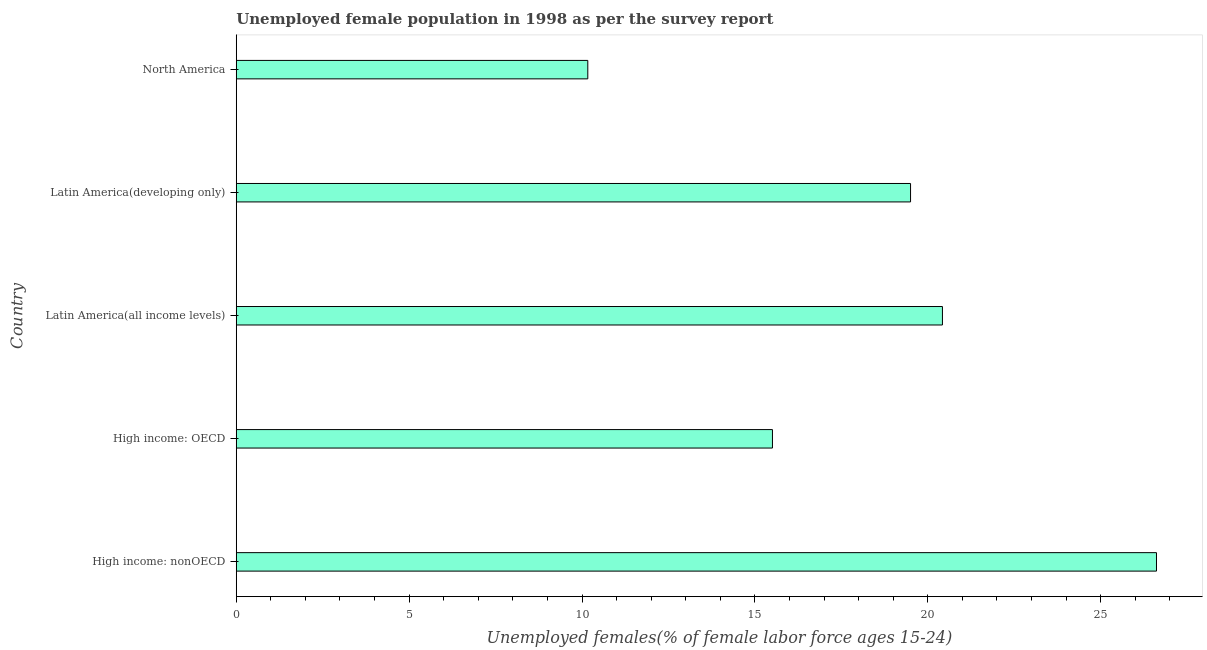Does the graph contain grids?
Provide a short and direct response. No. What is the title of the graph?
Offer a very short reply. Unemployed female population in 1998 as per the survey report. What is the label or title of the X-axis?
Your answer should be compact. Unemployed females(% of female labor force ages 15-24). What is the unemployed female youth in High income: nonOECD?
Offer a very short reply. 26.61. Across all countries, what is the maximum unemployed female youth?
Keep it short and to the point. 26.61. Across all countries, what is the minimum unemployed female youth?
Ensure brevity in your answer.  10.17. In which country was the unemployed female youth maximum?
Make the answer very short. High income: nonOECD. In which country was the unemployed female youth minimum?
Keep it short and to the point. North America. What is the sum of the unemployed female youth?
Make the answer very short. 92.21. What is the difference between the unemployed female youth in High income: OECD and Latin America(developing only)?
Your response must be concise. -3.99. What is the average unemployed female youth per country?
Ensure brevity in your answer.  18.44. What is the median unemployed female youth?
Make the answer very short. 19.5. What is the ratio of the unemployed female youth in High income: nonOECD to that in Latin America(developing only)?
Your answer should be compact. 1.36. Is the unemployed female youth in High income: OECD less than that in North America?
Ensure brevity in your answer.  No. Is the difference between the unemployed female youth in High income: OECD and Latin America(all income levels) greater than the difference between any two countries?
Ensure brevity in your answer.  No. What is the difference between the highest and the second highest unemployed female youth?
Keep it short and to the point. 6.19. Is the sum of the unemployed female youth in High income: OECD and North America greater than the maximum unemployed female youth across all countries?
Offer a very short reply. No. What is the difference between the highest and the lowest unemployed female youth?
Provide a succinct answer. 16.45. In how many countries, is the unemployed female youth greater than the average unemployed female youth taken over all countries?
Provide a short and direct response. 3. How many countries are there in the graph?
Your response must be concise. 5. What is the difference between two consecutive major ticks on the X-axis?
Provide a short and direct response. 5. Are the values on the major ticks of X-axis written in scientific E-notation?
Provide a succinct answer. No. What is the Unemployed females(% of female labor force ages 15-24) in High income: nonOECD?
Give a very brief answer. 26.61. What is the Unemployed females(% of female labor force ages 15-24) of High income: OECD?
Keep it short and to the point. 15.51. What is the Unemployed females(% of female labor force ages 15-24) of Latin America(all income levels)?
Ensure brevity in your answer.  20.42. What is the Unemployed females(% of female labor force ages 15-24) in Latin America(developing only)?
Keep it short and to the point. 19.5. What is the Unemployed females(% of female labor force ages 15-24) of North America?
Provide a succinct answer. 10.17. What is the difference between the Unemployed females(% of female labor force ages 15-24) in High income: nonOECD and High income: OECD?
Provide a short and direct response. 11.11. What is the difference between the Unemployed females(% of female labor force ages 15-24) in High income: nonOECD and Latin America(all income levels)?
Your answer should be compact. 6.19. What is the difference between the Unemployed females(% of female labor force ages 15-24) in High income: nonOECD and Latin America(developing only)?
Offer a terse response. 7.11. What is the difference between the Unemployed females(% of female labor force ages 15-24) in High income: nonOECD and North America?
Make the answer very short. 16.45. What is the difference between the Unemployed females(% of female labor force ages 15-24) in High income: OECD and Latin America(all income levels)?
Provide a short and direct response. -4.92. What is the difference between the Unemployed females(% of female labor force ages 15-24) in High income: OECD and Latin America(developing only)?
Your response must be concise. -3.99. What is the difference between the Unemployed females(% of female labor force ages 15-24) in High income: OECD and North America?
Offer a very short reply. 5.34. What is the difference between the Unemployed females(% of female labor force ages 15-24) in Latin America(all income levels) and Latin America(developing only)?
Keep it short and to the point. 0.92. What is the difference between the Unemployed females(% of female labor force ages 15-24) in Latin America(all income levels) and North America?
Ensure brevity in your answer.  10.26. What is the difference between the Unemployed females(% of female labor force ages 15-24) in Latin America(developing only) and North America?
Offer a terse response. 9.33. What is the ratio of the Unemployed females(% of female labor force ages 15-24) in High income: nonOECD to that in High income: OECD?
Your answer should be compact. 1.72. What is the ratio of the Unemployed females(% of female labor force ages 15-24) in High income: nonOECD to that in Latin America(all income levels)?
Keep it short and to the point. 1.3. What is the ratio of the Unemployed females(% of female labor force ages 15-24) in High income: nonOECD to that in Latin America(developing only)?
Give a very brief answer. 1.36. What is the ratio of the Unemployed females(% of female labor force ages 15-24) in High income: nonOECD to that in North America?
Ensure brevity in your answer.  2.62. What is the ratio of the Unemployed females(% of female labor force ages 15-24) in High income: OECD to that in Latin America(all income levels)?
Your answer should be compact. 0.76. What is the ratio of the Unemployed females(% of female labor force ages 15-24) in High income: OECD to that in Latin America(developing only)?
Provide a short and direct response. 0.8. What is the ratio of the Unemployed females(% of female labor force ages 15-24) in High income: OECD to that in North America?
Offer a terse response. 1.52. What is the ratio of the Unemployed females(% of female labor force ages 15-24) in Latin America(all income levels) to that in Latin America(developing only)?
Make the answer very short. 1.05. What is the ratio of the Unemployed females(% of female labor force ages 15-24) in Latin America(all income levels) to that in North America?
Provide a succinct answer. 2.01. What is the ratio of the Unemployed females(% of female labor force ages 15-24) in Latin America(developing only) to that in North America?
Keep it short and to the point. 1.92. 